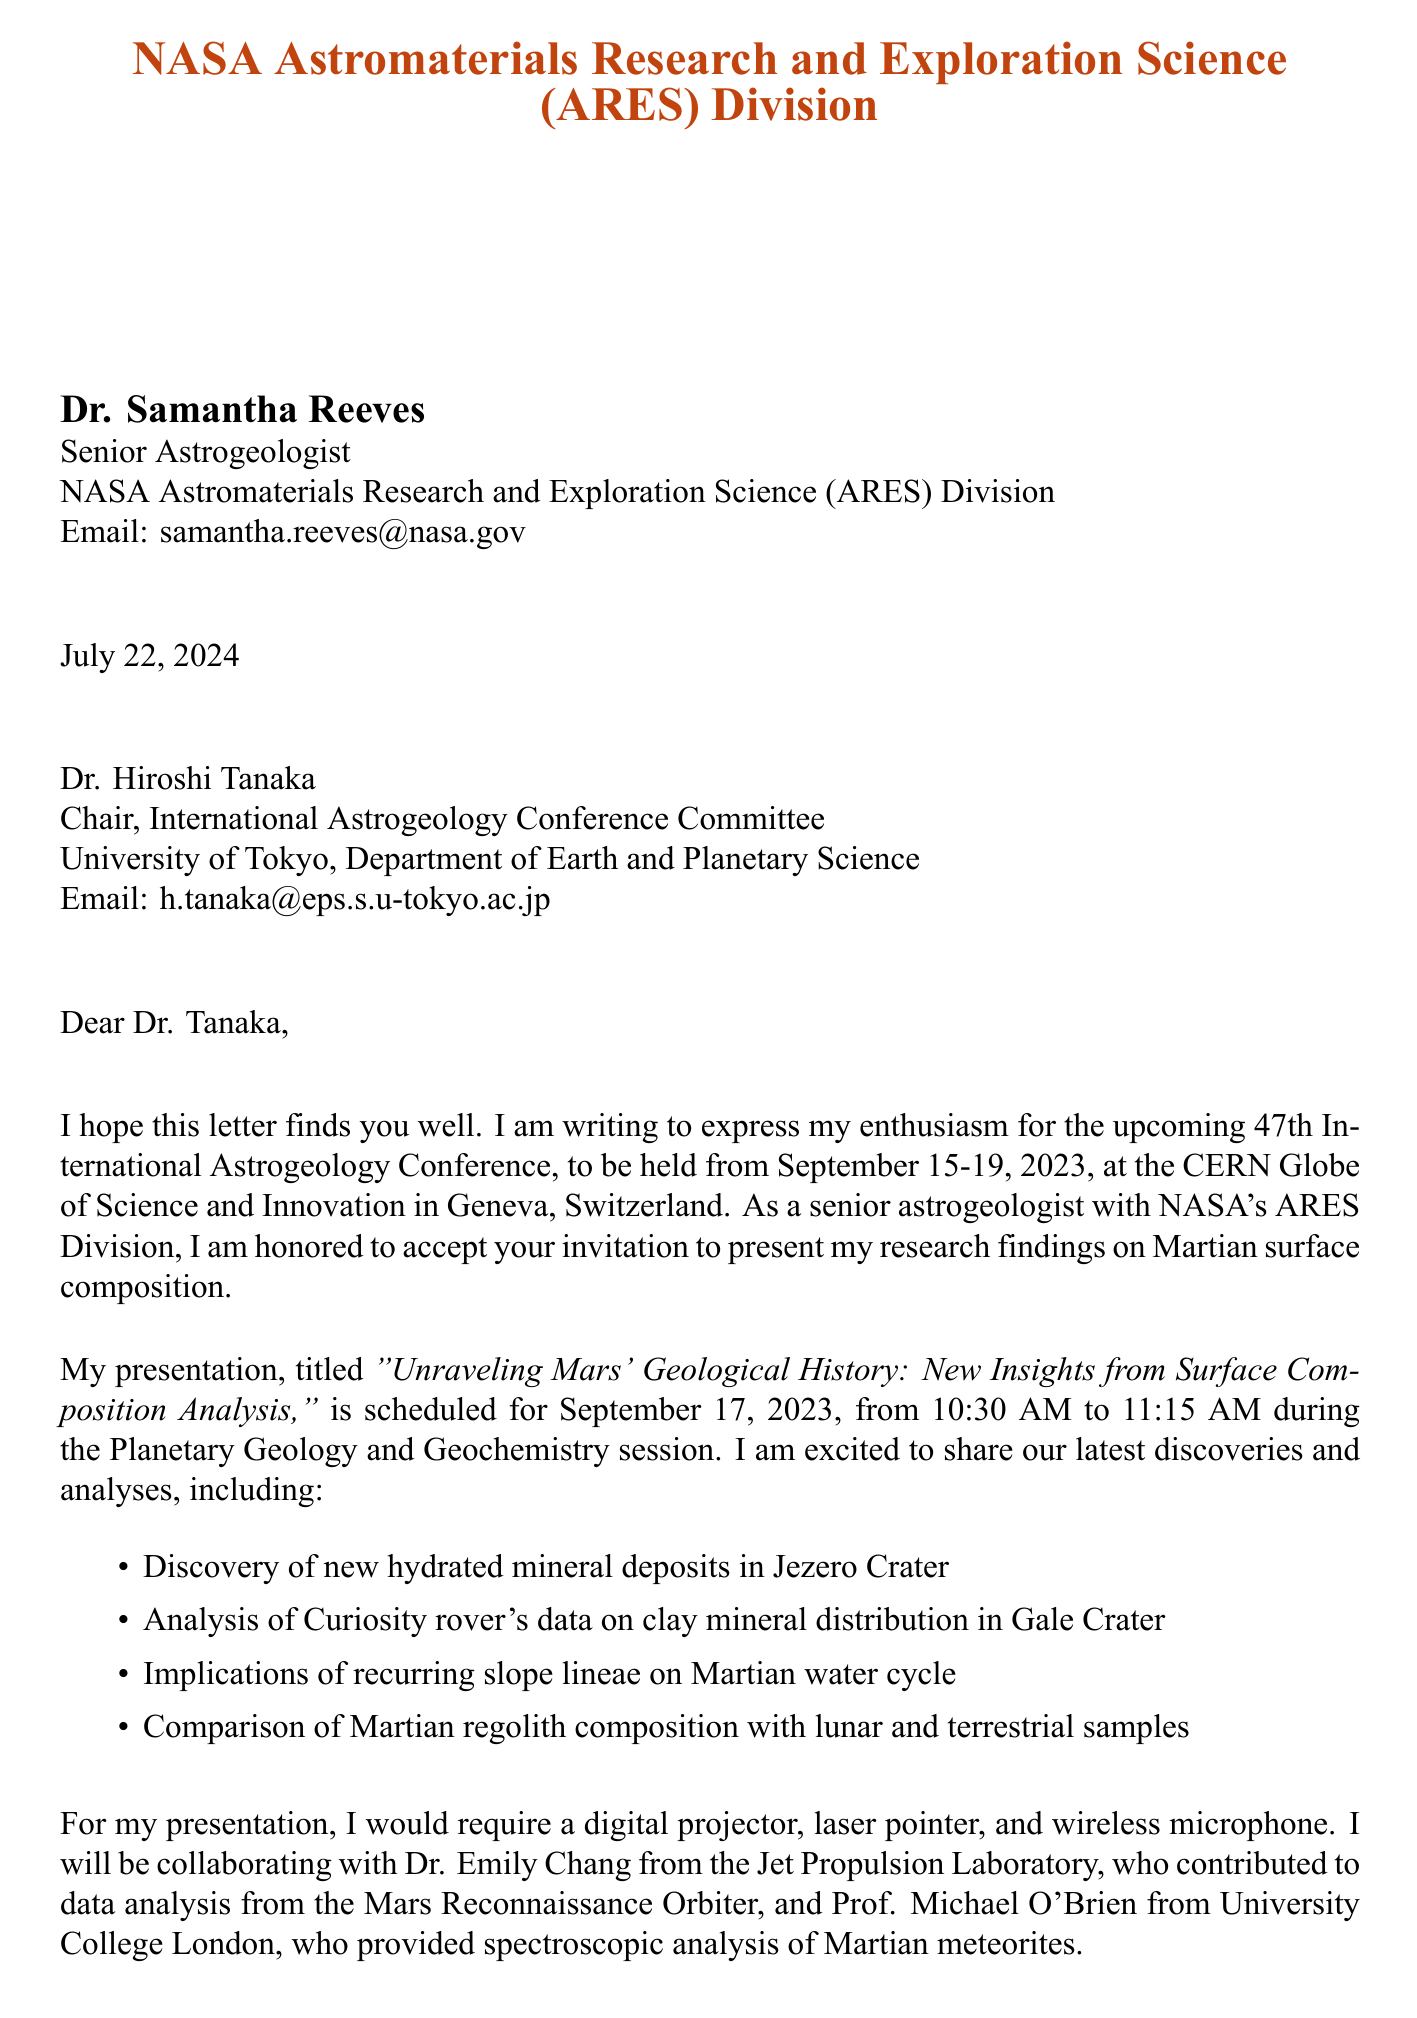What is the name of the conference? The document mentions the conference as the "47th International Astrogeology Conference."
Answer: 47th International Astrogeology Conference Who is the recipient of the letter? The letter is addressed to Dr. Hiroshi Tanaka, who is the Chair of the International Astrogeology Conference Committee.
Answer: Dr. Hiroshi Tanaka What is the date of the presentation? The presentation is scheduled on September 17, 2023, as indicated in the document.
Answer: September 17, 2023 What is the title of the presentation? The presentation title is stated in the document as "Unraveling Mars' Geological History: New Insights from Surface Composition Analysis."
Answer: Unraveling Mars' Geological History: New Insights from Surface Composition Analysis Which institution does Dr. Samantha Reeves represent? The document indicates that Dr. Samantha Reeves is from NASA's Astromaterials Research and Exploration Science (ARES) Division.
Answer: NASA Astromaterials Research and Exploration Science (ARES) Division What type of analysis is Dr. Emily Chang contributing? The document specifies that Dr. Emily Chang contributed to data analysis from the Mars Reconnaissance Orbiter.
Answer: Data analysis from Mars Reconnaissance Orbiter What equipment does Dr. Samantha Reeves require for her presentation? The document lists the equipment needed as a digital projector, laser pointer, and wireless microphone.
Answer: Digital projector, laser pointer, wireless microphone What is the location of the conference? The conference location is identified in the document as the CERN Globe of Science and Innovation in Geneva, Switzerland.
Answer: CERN Globe of Science and Innovation, Geneva, Switzerland What support was acknowledged for the research? The document mentions that the research was supported by NASA's Mars Exploration Program and the European Space Agency's ExoMars Programme.
Answer: NASA's Mars Exploration Program and the European Space Agency's ExoMars Programme 